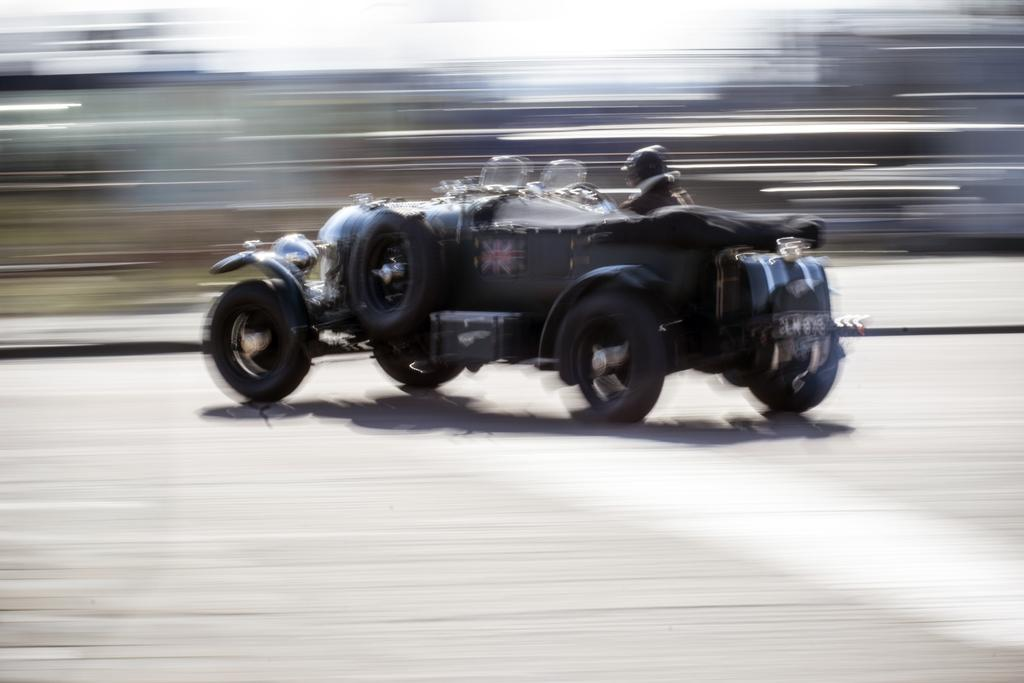Who is present in the image? There is a man in the image. What is the man doing in the image? The man is on a vehicle. Can you describe the setting of the image? The vehicle is on a road, and the background of the image is blurred. What type of calculator is the man using while adjusting the reading on the vehicle? There is no calculator or reading adjustment present in the image; the man is simply on a vehicle with a blurred background. 